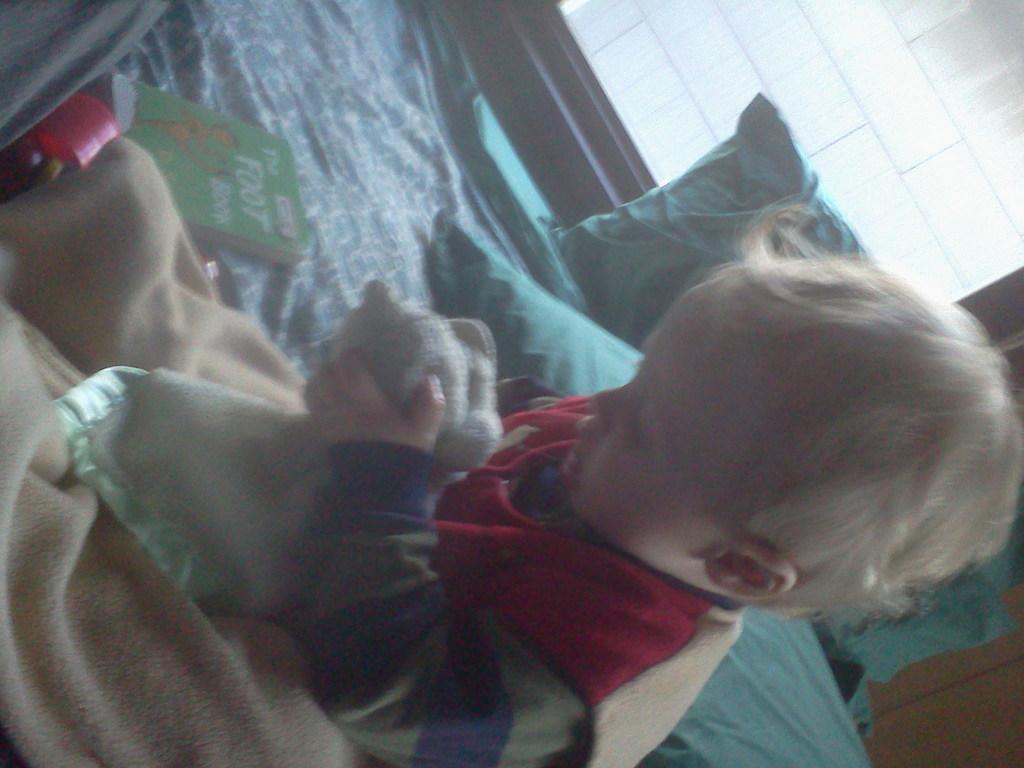Please provide a concise description of this image. In this image I can see the baby is sitting on the bed and holding something. I can see few pillows, book, cream color cloth and few objects on the bed. Back I can see the window and the wall. 